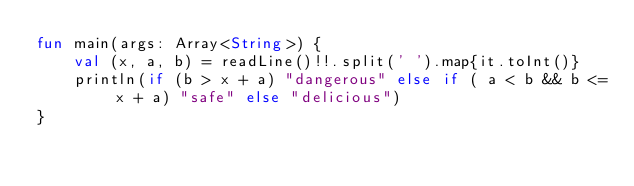<code> <loc_0><loc_0><loc_500><loc_500><_Kotlin_>fun main(args: Array<String>) {
    val (x, a, b) = readLine()!!.split(' ').map{it.toInt()}
    println(if (b > x + a) "dangerous" else if ( a < b && b <= x + a) "safe" else "delicious")
}</code> 